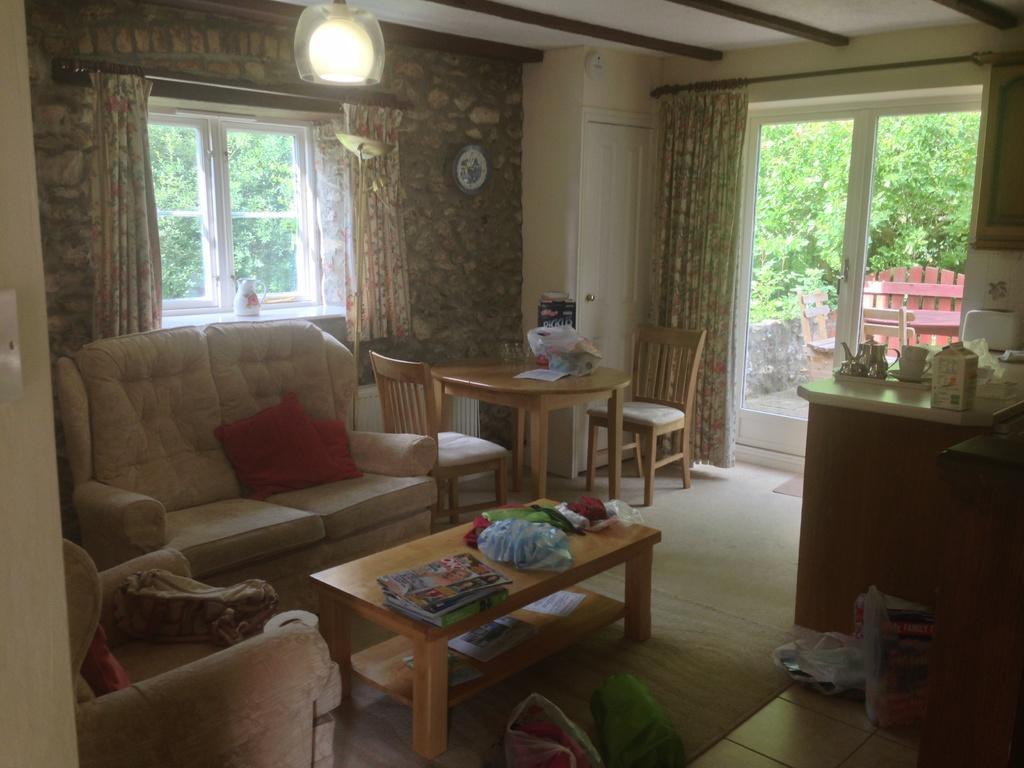In one or two sentences, can you explain what this image depicts? This is inside of the room we can see sofa,pillows,chairs,tables,curtains,glass window,wall. This is floor. On the table we can see things. From this glass window we can see trees. 